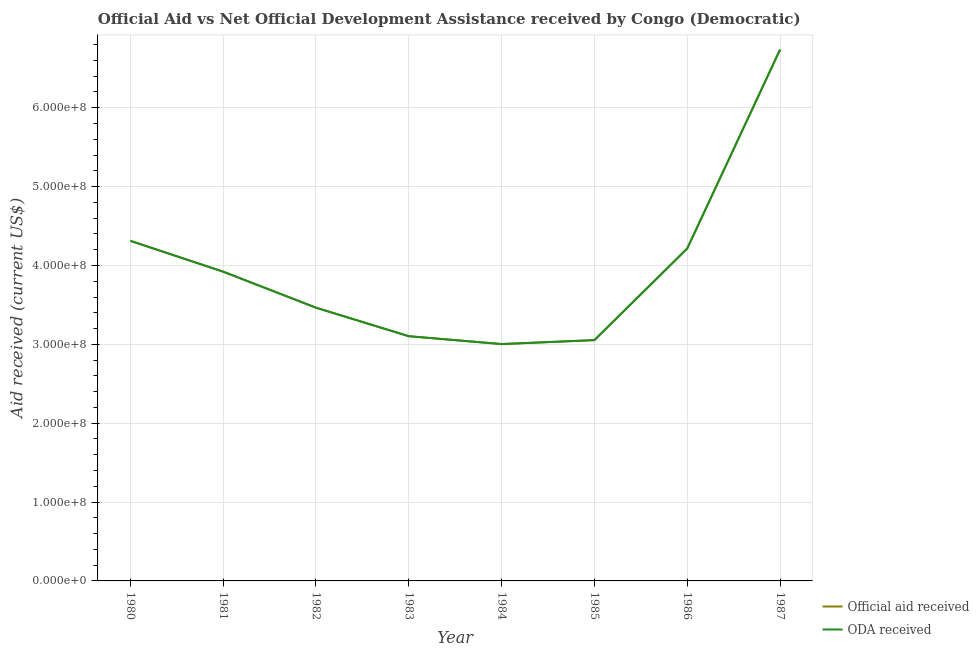How many different coloured lines are there?
Your response must be concise. 2. What is the official aid received in 1983?
Provide a short and direct response. 3.10e+08. Across all years, what is the maximum oda received?
Your response must be concise. 6.74e+08. Across all years, what is the minimum oda received?
Your answer should be very brief. 3.00e+08. In which year was the official aid received minimum?
Your answer should be very brief. 1984. What is the total oda received in the graph?
Offer a very short reply. 3.18e+09. What is the difference between the oda received in 1984 and that in 1987?
Give a very brief answer. -3.73e+08. What is the difference between the official aid received in 1986 and the oda received in 1981?
Offer a very short reply. 2.94e+07. What is the average official aid received per year?
Keep it short and to the point. 3.98e+08. In the year 1986, what is the difference between the oda received and official aid received?
Keep it short and to the point. 0. What is the ratio of the oda received in 1982 to that in 1985?
Provide a short and direct response. 1.13. Is the official aid received in 1980 less than that in 1986?
Ensure brevity in your answer.  No. What is the difference between the highest and the second highest official aid received?
Make the answer very short. 2.42e+08. What is the difference between the highest and the lowest oda received?
Make the answer very short. 3.73e+08. Is the sum of the oda received in 1981 and 1982 greater than the maximum official aid received across all years?
Ensure brevity in your answer.  Yes. Is the official aid received strictly greater than the oda received over the years?
Give a very brief answer. No. Is the oda received strictly less than the official aid received over the years?
Your response must be concise. No. What is the difference between two consecutive major ticks on the Y-axis?
Give a very brief answer. 1.00e+08. What is the title of the graph?
Make the answer very short. Official Aid vs Net Official Development Assistance received by Congo (Democratic) . What is the label or title of the Y-axis?
Keep it short and to the point. Aid received (current US$). What is the Aid received (current US$) in Official aid received in 1980?
Offer a terse response. 4.31e+08. What is the Aid received (current US$) of ODA received in 1980?
Give a very brief answer. 4.31e+08. What is the Aid received (current US$) in Official aid received in 1981?
Keep it short and to the point. 3.92e+08. What is the Aid received (current US$) of ODA received in 1981?
Offer a terse response. 3.92e+08. What is the Aid received (current US$) of Official aid received in 1982?
Offer a terse response. 3.46e+08. What is the Aid received (current US$) of ODA received in 1982?
Offer a very short reply. 3.46e+08. What is the Aid received (current US$) of Official aid received in 1983?
Offer a terse response. 3.10e+08. What is the Aid received (current US$) of ODA received in 1983?
Your answer should be very brief. 3.10e+08. What is the Aid received (current US$) in Official aid received in 1984?
Make the answer very short. 3.00e+08. What is the Aid received (current US$) of ODA received in 1984?
Make the answer very short. 3.00e+08. What is the Aid received (current US$) in Official aid received in 1985?
Offer a very short reply. 3.05e+08. What is the Aid received (current US$) in ODA received in 1985?
Offer a very short reply. 3.05e+08. What is the Aid received (current US$) in Official aid received in 1986?
Offer a terse response. 4.22e+08. What is the Aid received (current US$) in ODA received in 1986?
Provide a succinct answer. 4.22e+08. What is the Aid received (current US$) in Official aid received in 1987?
Ensure brevity in your answer.  6.74e+08. What is the Aid received (current US$) in ODA received in 1987?
Your answer should be very brief. 6.74e+08. Across all years, what is the maximum Aid received (current US$) in Official aid received?
Provide a succinct answer. 6.74e+08. Across all years, what is the maximum Aid received (current US$) in ODA received?
Offer a very short reply. 6.74e+08. Across all years, what is the minimum Aid received (current US$) of Official aid received?
Give a very brief answer. 3.00e+08. Across all years, what is the minimum Aid received (current US$) of ODA received?
Provide a short and direct response. 3.00e+08. What is the total Aid received (current US$) of Official aid received in the graph?
Make the answer very short. 3.18e+09. What is the total Aid received (current US$) in ODA received in the graph?
Make the answer very short. 3.18e+09. What is the difference between the Aid received (current US$) in Official aid received in 1980 and that in 1981?
Provide a short and direct response. 3.91e+07. What is the difference between the Aid received (current US$) of ODA received in 1980 and that in 1981?
Give a very brief answer. 3.91e+07. What is the difference between the Aid received (current US$) in Official aid received in 1980 and that in 1982?
Your answer should be very brief. 8.48e+07. What is the difference between the Aid received (current US$) of ODA received in 1980 and that in 1982?
Offer a terse response. 8.48e+07. What is the difference between the Aid received (current US$) in Official aid received in 1980 and that in 1983?
Your answer should be very brief. 1.21e+08. What is the difference between the Aid received (current US$) in ODA received in 1980 and that in 1983?
Your answer should be compact. 1.21e+08. What is the difference between the Aid received (current US$) in Official aid received in 1980 and that in 1984?
Offer a very short reply. 1.31e+08. What is the difference between the Aid received (current US$) of ODA received in 1980 and that in 1984?
Make the answer very short. 1.31e+08. What is the difference between the Aid received (current US$) of Official aid received in 1980 and that in 1985?
Keep it short and to the point. 1.26e+08. What is the difference between the Aid received (current US$) of ODA received in 1980 and that in 1985?
Offer a terse response. 1.26e+08. What is the difference between the Aid received (current US$) in Official aid received in 1980 and that in 1986?
Provide a short and direct response. 9.67e+06. What is the difference between the Aid received (current US$) in ODA received in 1980 and that in 1986?
Your answer should be very brief. 9.67e+06. What is the difference between the Aid received (current US$) in Official aid received in 1980 and that in 1987?
Give a very brief answer. -2.42e+08. What is the difference between the Aid received (current US$) in ODA received in 1980 and that in 1987?
Your answer should be very brief. -2.42e+08. What is the difference between the Aid received (current US$) in Official aid received in 1981 and that in 1982?
Provide a succinct answer. 4.57e+07. What is the difference between the Aid received (current US$) of ODA received in 1981 and that in 1982?
Provide a succinct answer. 4.57e+07. What is the difference between the Aid received (current US$) in Official aid received in 1981 and that in 1983?
Provide a succinct answer. 8.18e+07. What is the difference between the Aid received (current US$) of ODA received in 1981 and that in 1983?
Keep it short and to the point. 8.18e+07. What is the difference between the Aid received (current US$) in Official aid received in 1981 and that in 1984?
Offer a very short reply. 9.18e+07. What is the difference between the Aid received (current US$) in ODA received in 1981 and that in 1984?
Offer a terse response. 9.18e+07. What is the difference between the Aid received (current US$) in Official aid received in 1981 and that in 1985?
Give a very brief answer. 8.68e+07. What is the difference between the Aid received (current US$) in ODA received in 1981 and that in 1985?
Your answer should be compact. 8.68e+07. What is the difference between the Aid received (current US$) of Official aid received in 1981 and that in 1986?
Give a very brief answer. -2.94e+07. What is the difference between the Aid received (current US$) of ODA received in 1981 and that in 1986?
Ensure brevity in your answer.  -2.94e+07. What is the difference between the Aid received (current US$) of Official aid received in 1981 and that in 1987?
Your response must be concise. -2.82e+08. What is the difference between the Aid received (current US$) in ODA received in 1981 and that in 1987?
Provide a succinct answer. -2.82e+08. What is the difference between the Aid received (current US$) of Official aid received in 1982 and that in 1983?
Keep it short and to the point. 3.62e+07. What is the difference between the Aid received (current US$) of ODA received in 1982 and that in 1983?
Offer a very short reply. 3.62e+07. What is the difference between the Aid received (current US$) in Official aid received in 1982 and that in 1984?
Offer a terse response. 4.62e+07. What is the difference between the Aid received (current US$) of ODA received in 1982 and that in 1984?
Ensure brevity in your answer.  4.62e+07. What is the difference between the Aid received (current US$) of Official aid received in 1982 and that in 1985?
Keep it short and to the point. 4.11e+07. What is the difference between the Aid received (current US$) of ODA received in 1982 and that in 1985?
Keep it short and to the point. 4.11e+07. What is the difference between the Aid received (current US$) in Official aid received in 1982 and that in 1986?
Offer a terse response. -7.51e+07. What is the difference between the Aid received (current US$) of ODA received in 1982 and that in 1986?
Your response must be concise. -7.51e+07. What is the difference between the Aid received (current US$) of Official aid received in 1982 and that in 1987?
Make the answer very short. -3.27e+08. What is the difference between the Aid received (current US$) in ODA received in 1982 and that in 1987?
Your response must be concise. -3.27e+08. What is the difference between the Aid received (current US$) of Official aid received in 1983 and that in 1984?
Give a very brief answer. 9.98e+06. What is the difference between the Aid received (current US$) in ODA received in 1983 and that in 1984?
Offer a very short reply. 9.98e+06. What is the difference between the Aid received (current US$) of Official aid received in 1983 and that in 1985?
Keep it short and to the point. 4.94e+06. What is the difference between the Aid received (current US$) of ODA received in 1983 and that in 1985?
Offer a very short reply. 4.94e+06. What is the difference between the Aid received (current US$) in Official aid received in 1983 and that in 1986?
Keep it short and to the point. -1.11e+08. What is the difference between the Aid received (current US$) in ODA received in 1983 and that in 1986?
Your answer should be very brief. -1.11e+08. What is the difference between the Aid received (current US$) in Official aid received in 1983 and that in 1987?
Your answer should be very brief. -3.63e+08. What is the difference between the Aid received (current US$) of ODA received in 1983 and that in 1987?
Make the answer very short. -3.63e+08. What is the difference between the Aid received (current US$) of Official aid received in 1984 and that in 1985?
Offer a very short reply. -5.04e+06. What is the difference between the Aid received (current US$) of ODA received in 1984 and that in 1985?
Your answer should be compact. -5.04e+06. What is the difference between the Aid received (current US$) in Official aid received in 1984 and that in 1986?
Provide a succinct answer. -1.21e+08. What is the difference between the Aid received (current US$) in ODA received in 1984 and that in 1986?
Provide a short and direct response. -1.21e+08. What is the difference between the Aid received (current US$) in Official aid received in 1984 and that in 1987?
Offer a terse response. -3.73e+08. What is the difference between the Aid received (current US$) of ODA received in 1984 and that in 1987?
Your answer should be very brief. -3.73e+08. What is the difference between the Aid received (current US$) of Official aid received in 1985 and that in 1986?
Your response must be concise. -1.16e+08. What is the difference between the Aid received (current US$) in ODA received in 1985 and that in 1986?
Offer a terse response. -1.16e+08. What is the difference between the Aid received (current US$) of Official aid received in 1985 and that in 1987?
Your answer should be compact. -3.68e+08. What is the difference between the Aid received (current US$) of ODA received in 1985 and that in 1987?
Your answer should be compact. -3.68e+08. What is the difference between the Aid received (current US$) in Official aid received in 1986 and that in 1987?
Give a very brief answer. -2.52e+08. What is the difference between the Aid received (current US$) in ODA received in 1986 and that in 1987?
Offer a terse response. -2.52e+08. What is the difference between the Aid received (current US$) of Official aid received in 1980 and the Aid received (current US$) of ODA received in 1981?
Your answer should be very brief. 3.91e+07. What is the difference between the Aid received (current US$) in Official aid received in 1980 and the Aid received (current US$) in ODA received in 1982?
Offer a terse response. 8.48e+07. What is the difference between the Aid received (current US$) in Official aid received in 1980 and the Aid received (current US$) in ODA received in 1983?
Your response must be concise. 1.21e+08. What is the difference between the Aid received (current US$) in Official aid received in 1980 and the Aid received (current US$) in ODA received in 1984?
Offer a very short reply. 1.31e+08. What is the difference between the Aid received (current US$) in Official aid received in 1980 and the Aid received (current US$) in ODA received in 1985?
Give a very brief answer. 1.26e+08. What is the difference between the Aid received (current US$) of Official aid received in 1980 and the Aid received (current US$) of ODA received in 1986?
Your answer should be compact. 9.67e+06. What is the difference between the Aid received (current US$) of Official aid received in 1980 and the Aid received (current US$) of ODA received in 1987?
Your answer should be very brief. -2.42e+08. What is the difference between the Aid received (current US$) in Official aid received in 1981 and the Aid received (current US$) in ODA received in 1982?
Make the answer very short. 4.57e+07. What is the difference between the Aid received (current US$) in Official aid received in 1981 and the Aid received (current US$) in ODA received in 1983?
Your answer should be very brief. 8.18e+07. What is the difference between the Aid received (current US$) in Official aid received in 1981 and the Aid received (current US$) in ODA received in 1984?
Make the answer very short. 9.18e+07. What is the difference between the Aid received (current US$) of Official aid received in 1981 and the Aid received (current US$) of ODA received in 1985?
Offer a terse response. 8.68e+07. What is the difference between the Aid received (current US$) of Official aid received in 1981 and the Aid received (current US$) of ODA received in 1986?
Your answer should be very brief. -2.94e+07. What is the difference between the Aid received (current US$) in Official aid received in 1981 and the Aid received (current US$) in ODA received in 1987?
Keep it short and to the point. -2.82e+08. What is the difference between the Aid received (current US$) in Official aid received in 1982 and the Aid received (current US$) in ODA received in 1983?
Ensure brevity in your answer.  3.62e+07. What is the difference between the Aid received (current US$) of Official aid received in 1982 and the Aid received (current US$) of ODA received in 1984?
Your answer should be very brief. 4.62e+07. What is the difference between the Aid received (current US$) in Official aid received in 1982 and the Aid received (current US$) in ODA received in 1985?
Offer a very short reply. 4.11e+07. What is the difference between the Aid received (current US$) of Official aid received in 1982 and the Aid received (current US$) of ODA received in 1986?
Keep it short and to the point. -7.51e+07. What is the difference between the Aid received (current US$) in Official aid received in 1982 and the Aid received (current US$) in ODA received in 1987?
Make the answer very short. -3.27e+08. What is the difference between the Aid received (current US$) in Official aid received in 1983 and the Aid received (current US$) in ODA received in 1984?
Keep it short and to the point. 9.98e+06. What is the difference between the Aid received (current US$) in Official aid received in 1983 and the Aid received (current US$) in ODA received in 1985?
Offer a very short reply. 4.94e+06. What is the difference between the Aid received (current US$) in Official aid received in 1983 and the Aid received (current US$) in ODA received in 1986?
Offer a very short reply. -1.11e+08. What is the difference between the Aid received (current US$) in Official aid received in 1983 and the Aid received (current US$) in ODA received in 1987?
Your response must be concise. -3.63e+08. What is the difference between the Aid received (current US$) in Official aid received in 1984 and the Aid received (current US$) in ODA received in 1985?
Keep it short and to the point. -5.04e+06. What is the difference between the Aid received (current US$) in Official aid received in 1984 and the Aid received (current US$) in ODA received in 1986?
Ensure brevity in your answer.  -1.21e+08. What is the difference between the Aid received (current US$) in Official aid received in 1984 and the Aid received (current US$) in ODA received in 1987?
Provide a short and direct response. -3.73e+08. What is the difference between the Aid received (current US$) of Official aid received in 1985 and the Aid received (current US$) of ODA received in 1986?
Keep it short and to the point. -1.16e+08. What is the difference between the Aid received (current US$) of Official aid received in 1985 and the Aid received (current US$) of ODA received in 1987?
Give a very brief answer. -3.68e+08. What is the difference between the Aid received (current US$) of Official aid received in 1986 and the Aid received (current US$) of ODA received in 1987?
Offer a terse response. -2.52e+08. What is the average Aid received (current US$) of Official aid received per year?
Offer a terse response. 3.98e+08. What is the average Aid received (current US$) of ODA received per year?
Offer a terse response. 3.98e+08. In the year 1980, what is the difference between the Aid received (current US$) in Official aid received and Aid received (current US$) in ODA received?
Give a very brief answer. 0. In the year 1981, what is the difference between the Aid received (current US$) of Official aid received and Aid received (current US$) of ODA received?
Offer a terse response. 0. In the year 1983, what is the difference between the Aid received (current US$) of Official aid received and Aid received (current US$) of ODA received?
Offer a terse response. 0. In the year 1987, what is the difference between the Aid received (current US$) of Official aid received and Aid received (current US$) of ODA received?
Offer a terse response. 0. What is the ratio of the Aid received (current US$) of Official aid received in 1980 to that in 1981?
Provide a short and direct response. 1.1. What is the ratio of the Aid received (current US$) of ODA received in 1980 to that in 1981?
Make the answer very short. 1.1. What is the ratio of the Aid received (current US$) in Official aid received in 1980 to that in 1982?
Your answer should be compact. 1.24. What is the ratio of the Aid received (current US$) of ODA received in 1980 to that in 1982?
Provide a short and direct response. 1.24. What is the ratio of the Aid received (current US$) in Official aid received in 1980 to that in 1983?
Your response must be concise. 1.39. What is the ratio of the Aid received (current US$) in ODA received in 1980 to that in 1983?
Your answer should be compact. 1.39. What is the ratio of the Aid received (current US$) of Official aid received in 1980 to that in 1984?
Your response must be concise. 1.44. What is the ratio of the Aid received (current US$) in ODA received in 1980 to that in 1984?
Give a very brief answer. 1.44. What is the ratio of the Aid received (current US$) of Official aid received in 1980 to that in 1985?
Provide a short and direct response. 1.41. What is the ratio of the Aid received (current US$) of ODA received in 1980 to that in 1985?
Your answer should be compact. 1.41. What is the ratio of the Aid received (current US$) of Official aid received in 1980 to that in 1986?
Offer a very short reply. 1.02. What is the ratio of the Aid received (current US$) of ODA received in 1980 to that in 1986?
Give a very brief answer. 1.02. What is the ratio of the Aid received (current US$) in Official aid received in 1980 to that in 1987?
Provide a short and direct response. 0.64. What is the ratio of the Aid received (current US$) of ODA received in 1980 to that in 1987?
Give a very brief answer. 0.64. What is the ratio of the Aid received (current US$) in Official aid received in 1981 to that in 1982?
Keep it short and to the point. 1.13. What is the ratio of the Aid received (current US$) of ODA received in 1981 to that in 1982?
Provide a short and direct response. 1.13. What is the ratio of the Aid received (current US$) in Official aid received in 1981 to that in 1983?
Keep it short and to the point. 1.26. What is the ratio of the Aid received (current US$) in ODA received in 1981 to that in 1983?
Offer a terse response. 1.26. What is the ratio of the Aid received (current US$) of Official aid received in 1981 to that in 1984?
Your answer should be compact. 1.31. What is the ratio of the Aid received (current US$) in ODA received in 1981 to that in 1984?
Offer a very short reply. 1.31. What is the ratio of the Aid received (current US$) of Official aid received in 1981 to that in 1985?
Keep it short and to the point. 1.28. What is the ratio of the Aid received (current US$) in ODA received in 1981 to that in 1985?
Make the answer very short. 1.28. What is the ratio of the Aid received (current US$) in Official aid received in 1981 to that in 1986?
Provide a short and direct response. 0.93. What is the ratio of the Aid received (current US$) of ODA received in 1981 to that in 1986?
Keep it short and to the point. 0.93. What is the ratio of the Aid received (current US$) in Official aid received in 1981 to that in 1987?
Provide a succinct answer. 0.58. What is the ratio of the Aid received (current US$) of ODA received in 1981 to that in 1987?
Provide a succinct answer. 0.58. What is the ratio of the Aid received (current US$) in Official aid received in 1982 to that in 1983?
Your response must be concise. 1.12. What is the ratio of the Aid received (current US$) of ODA received in 1982 to that in 1983?
Make the answer very short. 1.12. What is the ratio of the Aid received (current US$) of Official aid received in 1982 to that in 1984?
Make the answer very short. 1.15. What is the ratio of the Aid received (current US$) in ODA received in 1982 to that in 1984?
Your answer should be compact. 1.15. What is the ratio of the Aid received (current US$) of Official aid received in 1982 to that in 1985?
Offer a terse response. 1.13. What is the ratio of the Aid received (current US$) of ODA received in 1982 to that in 1985?
Give a very brief answer. 1.13. What is the ratio of the Aid received (current US$) of Official aid received in 1982 to that in 1986?
Your answer should be very brief. 0.82. What is the ratio of the Aid received (current US$) in ODA received in 1982 to that in 1986?
Your response must be concise. 0.82. What is the ratio of the Aid received (current US$) in Official aid received in 1982 to that in 1987?
Provide a short and direct response. 0.51. What is the ratio of the Aid received (current US$) in ODA received in 1982 to that in 1987?
Offer a very short reply. 0.51. What is the ratio of the Aid received (current US$) in Official aid received in 1983 to that in 1984?
Offer a terse response. 1.03. What is the ratio of the Aid received (current US$) of ODA received in 1983 to that in 1984?
Ensure brevity in your answer.  1.03. What is the ratio of the Aid received (current US$) in Official aid received in 1983 to that in 1985?
Your answer should be compact. 1.02. What is the ratio of the Aid received (current US$) in ODA received in 1983 to that in 1985?
Your answer should be very brief. 1.02. What is the ratio of the Aid received (current US$) in Official aid received in 1983 to that in 1986?
Offer a very short reply. 0.74. What is the ratio of the Aid received (current US$) in ODA received in 1983 to that in 1986?
Ensure brevity in your answer.  0.74. What is the ratio of the Aid received (current US$) of Official aid received in 1983 to that in 1987?
Make the answer very short. 0.46. What is the ratio of the Aid received (current US$) of ODA received in 1983 to that in 1987?
Provide a succinct answer. 0.46. What is the ratio of the Aid received (current US$) of Official aid received in 1984 to that in 1985?
Your answer should be compact. 0.98. What is the ratio of the Aid received (current US$) in ODA received in 1984 to that in 1985?
Offer a terse response. 0.98. What is the ratio of the Aid received (current US$) in Official aid received in 1984 to that in 1986?
Your response must be concise. 0.71. What is the ratio of the Aid received (current US$) in ODA received in 1984 to that in 1986?
Give a very brief answer. 0.71. What is the ratio of the Aid received (current US$) of Official aid received in 1984 to that in 1987?
Offer a terse response. 0.45. What is the ratio of the Aid received (current US$) of ODA received in 1984 to that in 1987?
Offer a very short reply. 0.45. What is the ratio of the Aid received (current US$) of Official aid received in 1985 to that in 1986?
Make the answer very short. 0.72. What is the ratio of the Aid received (current US$) of ODA received in 1985 to that in 1986?
Offer a terse response. 0.72. What is the ratio of the Aid received (current US$) in Official aid received in 1985 to that in 1987?
Ensure brevity in your answer.  0.45. What is the ratio of the Aid received (current US$) in ODA received in 1985 to that in 1987?
Ensure brevity in your answer.  0.45. What is the ratio of the Aid received (current US$) of Official aid received in 1986 to that in 1987?
Provide a short and direct response. 0.63. What is the ratio of the Aid received (current US$) of ODA received in 1986 to that in 1987?
Offer a very short reply. 0.63. What is the difference between the highest and the second highest Aid received (current US$) in Official aid received?
Ensure brevity in your answer.  2.42e+08. What is the difference between the highest and the second highest Aid received (current US$) in ODA received?
Ensure brevity in your answer.  2.42e+08. What is the difference between the highest and the lowest Aid received (current US$) in Official aid received?
Make the answer very short. 3.73e+08. What is the difference between the highest and the lowest Aid received (current US$) of ODA received?
Your response must be concise. 3.73e+08. 